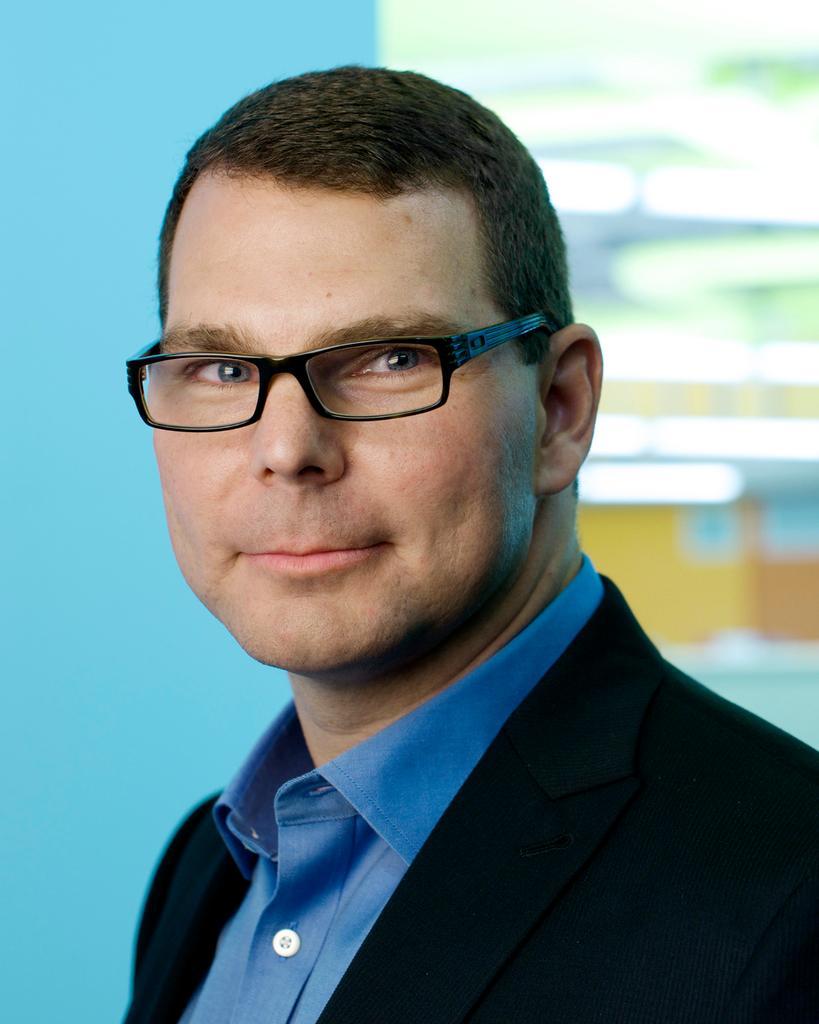Can you describe this image briefly? In this picture we can see a person smiling. Background is blurry. 